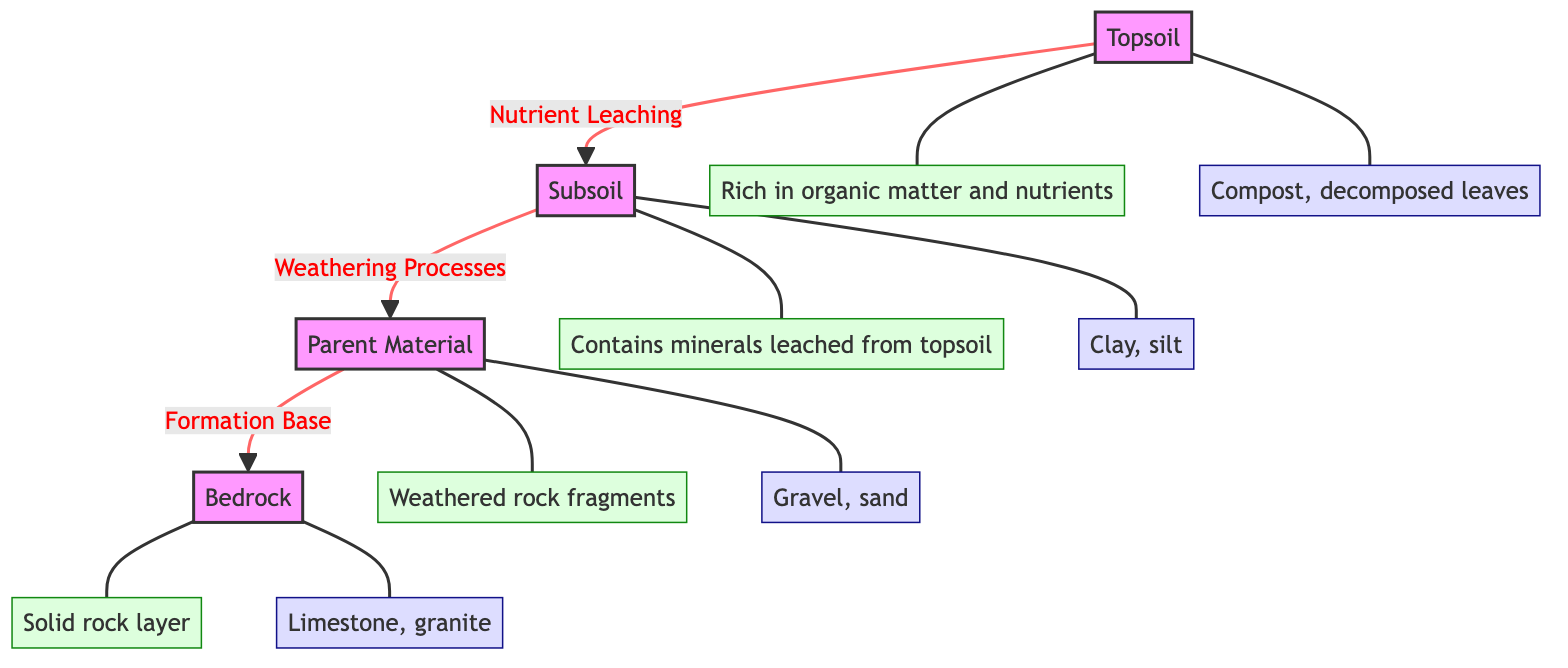What are the four main layers of soil shown in the diagram? The diagram displays four main layers: Topsoil, Subsoil, Parent Material, and Bedrock. These can be found as individual nodes in the diagram representing the hierarchy of soil layers.
Answer: Topsoil, Subsoil, Parent Material, Bedrock What does the subsoil mainly contain? The description associated with the subsoil node states that it contains minerals leached from the topsoil. This can be found directly connected to the subsoil node in the diagram.
Answer: Minerals What is the relationship between topsoil and subsoil? The diagram indicates a directional flow labeled "Nutrient Leaching" from the topsoil to the subsoil, showing that nutrients from the topsoil flow down into the subsoil.
Answer: Nutrient Leaching What type of materials are found in the parent material layer? According to the parent material description node, it consists of weathered rock fragments. This information is clearly stated in the associated description node linked to the parent material.
Answer: Weathered rock fragments What example is given for the topsoil layer? The example node connected to the topsoil layer highlights that examples include compost and decomposed leaves, which is explicitly detailed in the diagram.
Answer: Compost, decomposed leaves How many distinct soil layers are illustrated in the diagram? By counting the nodes representing the layers, there are four distinct layers denoted in the diagram. This is a straightforward analysis of the nodes representing soil layers.
Answer: Four What process occurs between the subsoil and parent material layers? The diagram states "Weathering Processes" as the connecting relationship from the subsoil to the parent material, indicating a process of change or breakdown between these layers.
Answer: Weathering Processes Which layer is considered the solid rock base? The bedrock layer is specifically described as the solid rock layer, making it the foundational base of the soil structure represented in the diagram.
Answer: Bedrock What does the bedrock primarily consist of? The example associated with the bedrock node cites limestone and granite as the materials found in this solid rock layer, as indicated in the connected example node.
Answer: Limestone, granite 